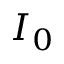<formula> <loc_0><loc_0><loc_500><loc_500>I _ { 0 }</formula> 